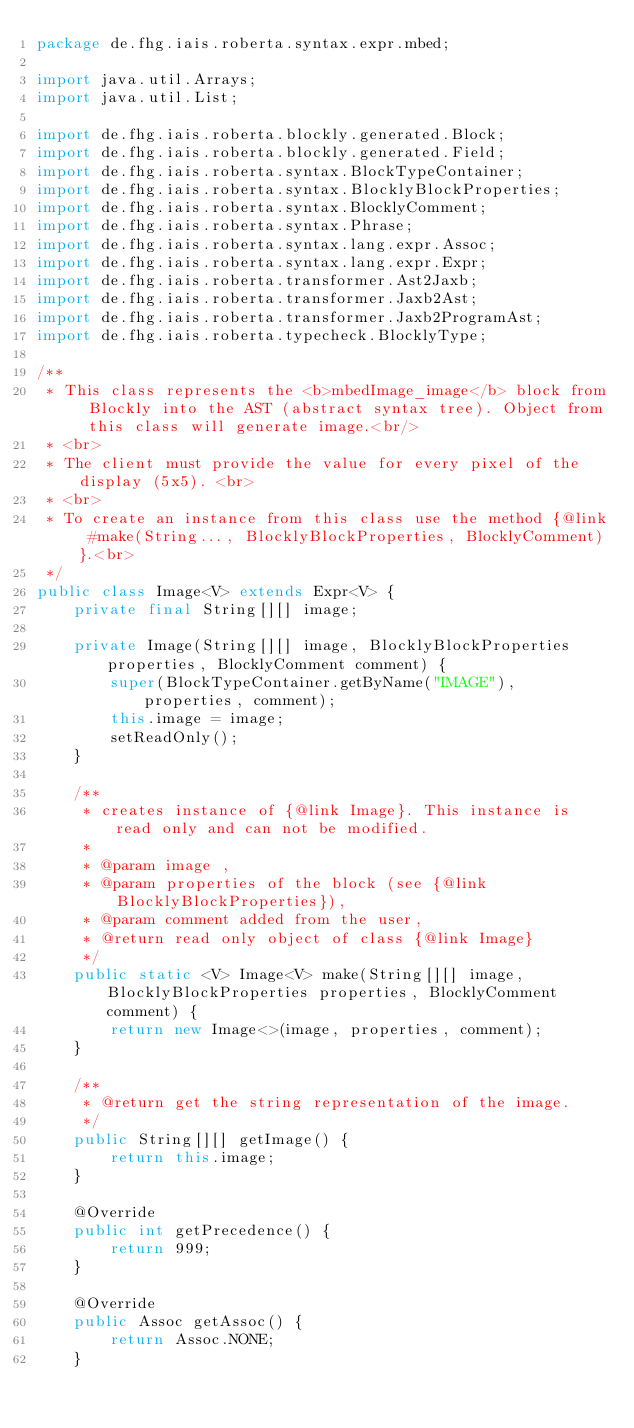Convert code to text. <code><loc_0><loc_0><loc_500><loc_500><_Java_>package de.fhg.iais.roberta.syntax.expr.mbed;

import java.util.Arrays;
import java.util.List;

import de.fhg.iais.roberta.blockly.generated.Block;
import de.fhg.iais.roberta.blockly.generated.Field;
import de.fhg.iais.roberta.syntax.BlockTypeContainer;
import de.fhg.iais.roberta.syntax.BlocklyBlockProperties;
import de.fhg.iais.roberta.syntax.BlocklyComment;
import de.fhg.iais.roberta.syntax.Phrase;
import de.fhg.iais.roberta.syntax.lang.expr.Assoc;
import de.fhg.iais.roberta.syntax.lang.expr.Expr;
import de.fhg.iais.roberta.transformer.Ast2Jaxb;
import de.fhg.iais.roberta.transformer.Jaxb2Ast;
import de.fhg.iais.roberta.transformer.Jaxb2ProgramAst;
import de.fhg.iais.roberta.typecheck.BlocklyType;

/**
 * This class represents the <b>mbedImage_image</b> block from Blockly into the AST (abstract syntax tree). Object from this class will generate image.<br/>
 * <br>
 * The client must provide the value for every pixel of the display (5x5). <br>
 * <br>
 * To create an instance from this class use the method {@link #make(String..., BlocklyBlockProperties, BlocklyComment)}.<br>
 */
public class Image<V> extends Expr<V> {
    private final String[][] image;

    private Image(String[][] image, BlocklyBlockProperties properties, BlocklyComment comment) {
        super(BlockTypeContainer.getByName("IMAGE"), properties, comment);
        this.image = image;
        setReadOnly();
    }

    /**
     * creates instance of {@link Image}. This instance is read only and can not be modified.
     *
     * @param image ,
     * @param properties of the block (see {@link BlocklyBlockProperties}),
     * @param comment added from the user,
     * @return read only object of class {@link Image}
     */
    public static <V> Image<V> make(String[][] image, BlocklyBlockProperties properties, BlocklyComment comment) {
        return new Image<>(image, properties, comment);
    }

    /**
     * @return get the string representation of the image.
     */
    public String[][] getImage() {
        return this.image;
    }

    @Override
    public int getPrecedence() {
        return 999;
    }

    @Override
    public Assoc getAssoc() {
        return Assoc.NONE;
    }
</code> 